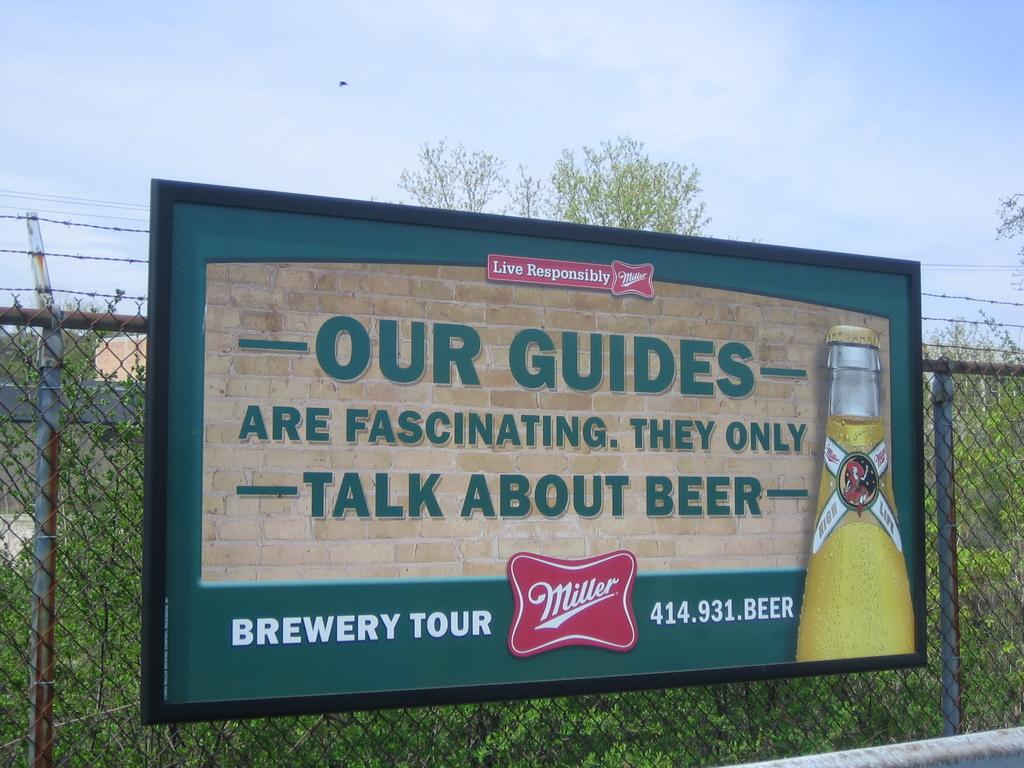What is on the mask in the image? There is a hoarding on a mask in the image. What can be seen on the backside of the mesh? There are plants on the backside of the mesh. How would you describe the sky in the image? The sky is cloudy in the image. What type of flesh can be seen on the mask in the image? There is no flesh visible on the mask in the image; it has a hoarding on it. What type of song can be heard playing in the background of the image? There is no song playing in the background of the image. 